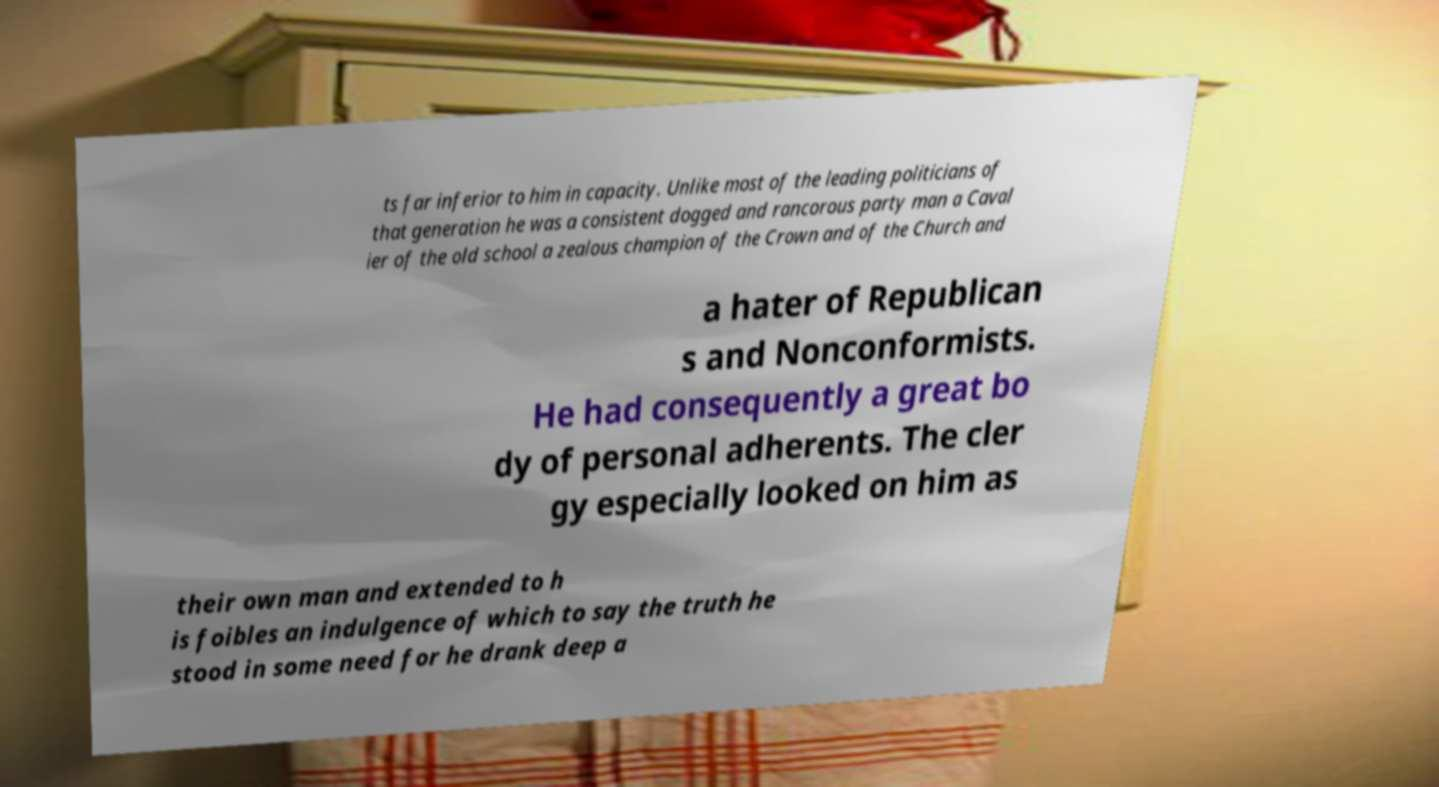Could you extract and type out the text from this image? ts far inferior to him in capacity. Unlike most of the leading politicians of that generation he was a consistent dogged and rancorous party man a Caval ier of the old school a zealous champion of the Crown and of the Church and a hater of Republican s and Nonconformists. He had consequently a great bo dy of personal adherents. The cler gy especially looked on him as their own man and extended to h is foibles an indulgence of which to say the truth he stood in some need for he drank deep a 